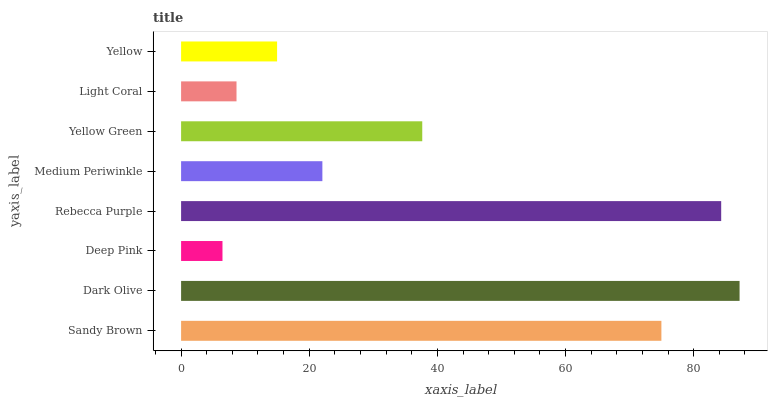Is Deep Pink the minimum?
Answer yes or no. Yes. Is Dark Olive the maximum?
Answer yes or no. Yes. Is Dark Olive the minimum?
Answer yes or no. No. Is Deep Pink the maximum?
Answer yes or no. No. Is Dark Olive greater than Deep Pink?
Answer yes or no. Yes. Is Deep Pink less than Dark Olive?
Answer yes or no. Yes. Is Deep Pink greater than Dark Olive?
Answer yes or no. No. Is Dark Olive less than Deep Pink?
Answer yes or no. No. Is Yellow Green the high median?
Answer yes or no. Yes. Is Medium Periwinkle the low median?
Answer yes or no. Yes. Is Yellow the high median?
Answer yes or no. No. Is Sandy Brown the low median?
Answer yes or no. No. 